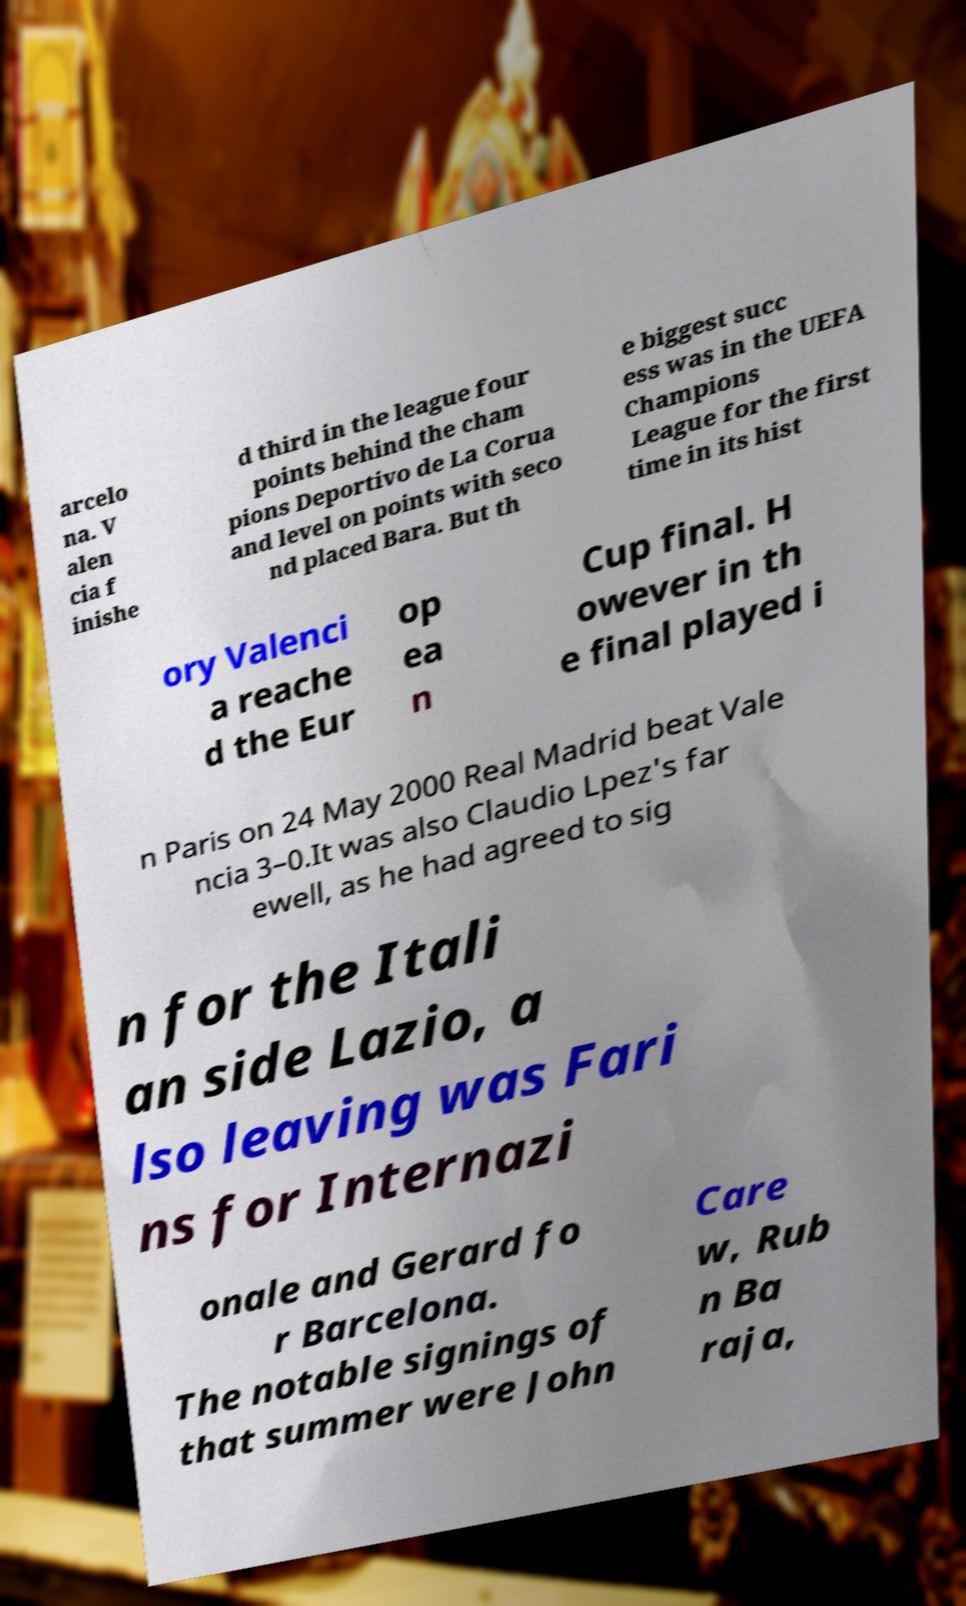What messages or text are displayed in this image? I need them in a readable, typed format. arcelo na. V alen cia f inishe d third in the league four points behind the cham pions Deportivo de La Corua and level on points with seco nd placed Bara. But th e biggest succ ess was in the UEFA Champions League for the first time in its hist ory Valenci a reache d the Eur op ea n Cup final. H owever in th e final played i n Paris on 24 May 2000 Real Madrid beat Vale ncia 3–0.It was also Claudio Lpez's far ewell, as he had agreed to sig n for the Itali an side Lazio, a lso leaving was Fari ns for Internazi onale and Gerard fo r Barcelona. The notable signings of that summer were John Care w, Rub n Ba raja, 